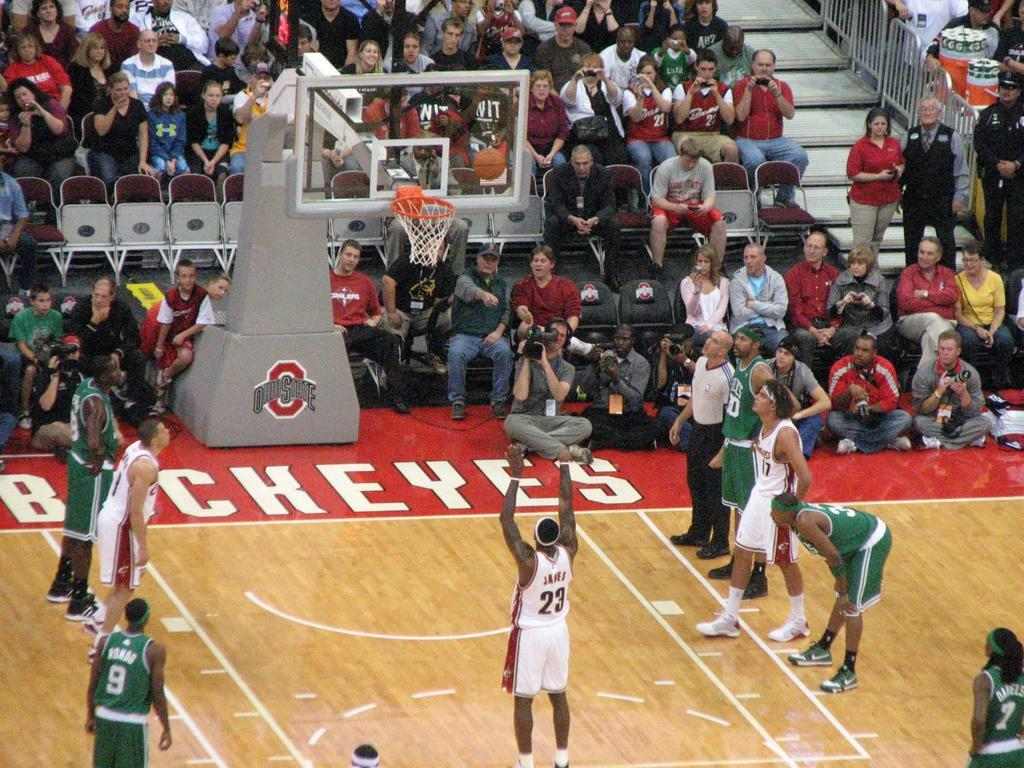<image>
Describe the image concisely. Player Number 23 for the Ohio State Buckeyes is making a free throw. 